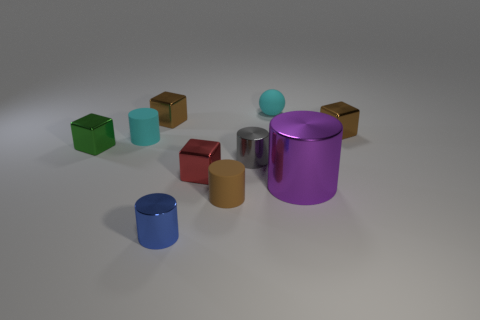Are there more metallic cylinders that are on the left side of the brown rubber cylinder than gray cylinders behind the tiny sphere?
Keep it short and to the point. Yes. What is the material of the purple thing that is the same shape as the gray object?
Make the answer very short. Metal. Is there anything else that has the same size as the cyan rubber cylinder?
Your answer should be very brief. Yes. There is a thing on the left side of the cyan cylinder; is its color the same as the rubber cylinder to the right of the small blue cylinder?
Your answer should be very brief. No. What is the shape of the small red shiny object?
Offer a very short reply. Cube. Are there more cyan things in front of the big metal thing than blue metallic cylinders?
Offer a very short reply. No. The brown shiny thing on the right side of the gray cylinder has what shape?
Ensure brevity in your answer.  Cube. How many other things are there of the same shape as the big purple thing?
Your answer should be very brief. 4. Does the tiny object that is to the right of the sphere have the same material as the large thing?
Offer a terse response. Yes. Is the number of small cyan rubber things to the left of the small gray cylinder the same as the number of tiny metal things to the right of the green block?
Your response must be concise. No. 